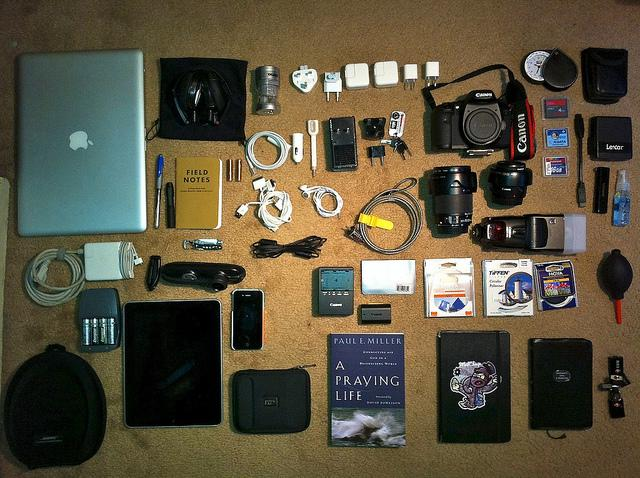The book was based on a series of what by the author? Please explain your reasoning. seminars. The book on the table has words on it that explain the title. 